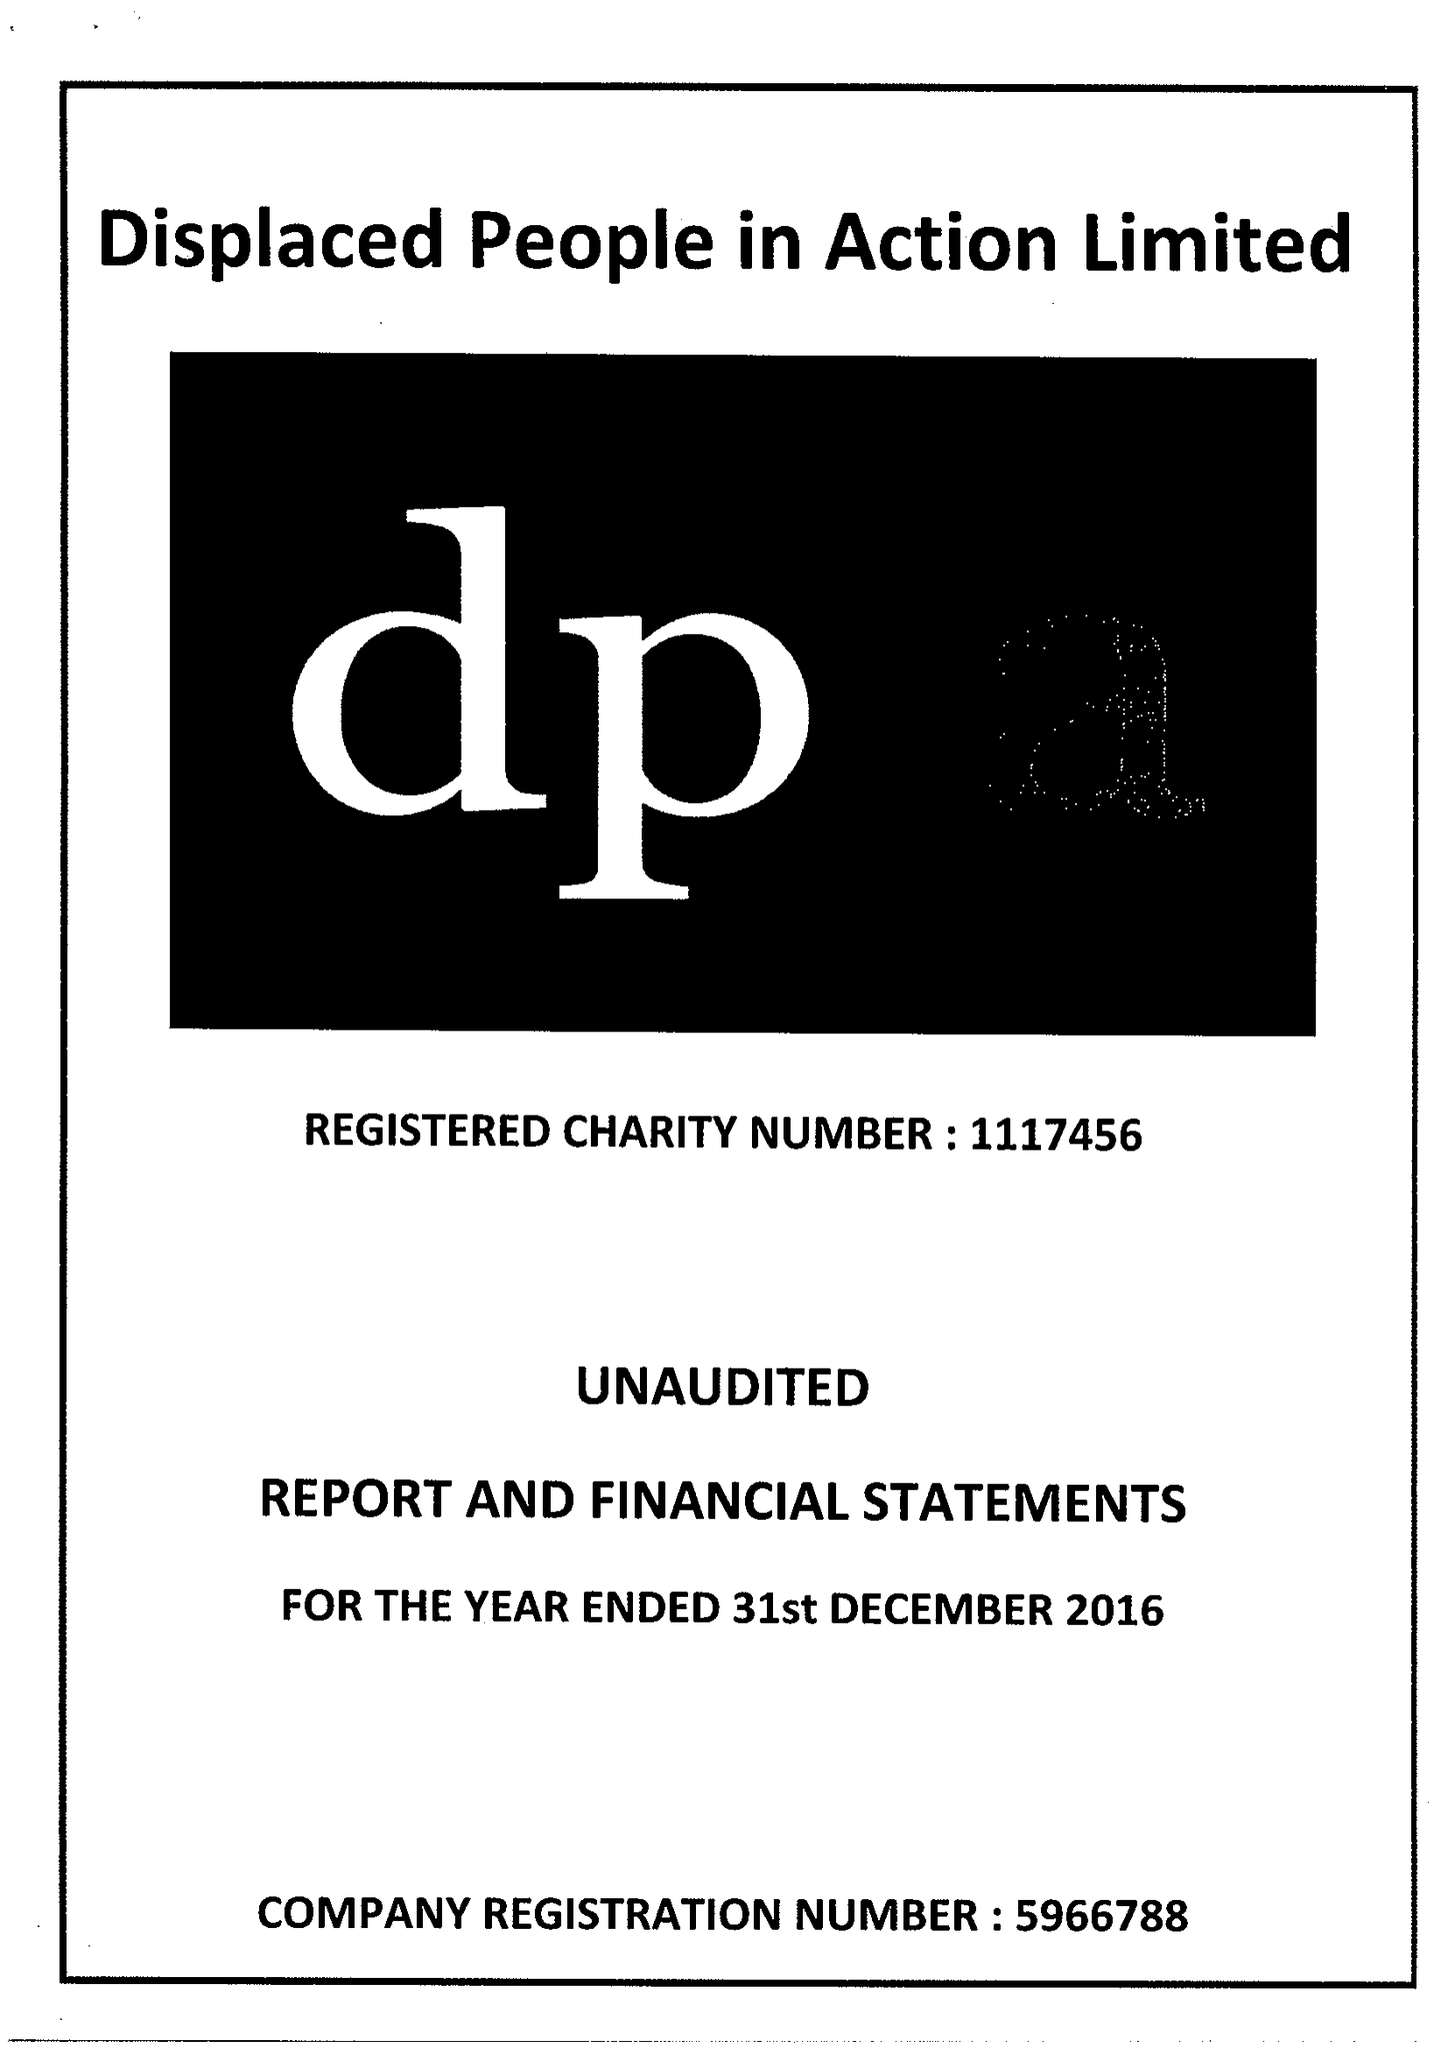What is the value for the address__street_line?
Answer the question using a single word or phrase. FITZALAN PLACE 